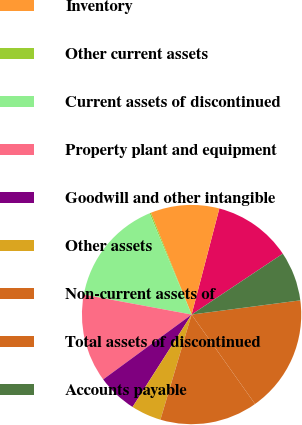<chart> <loc_0><loc_0><loc_500><loc_500><pie_chart><fcel>Accounts receivable<fcel>Inventory<fcel>Other current assets<fcel>Current assets of discontinued<fcel>Property plant and equipment<fcel>Goodwill and other intangible<fcel>Other assets<fcel>Non-current assets of<fcel>Total assets of discontinued<fcel>Accounts payable<nl><fcel>11.56%<fcel>10.14%<fcel>0.19%<fcel>15.83%<fcel>12.99%<fcel>5.88%<fcel>4.46%<fcel>14.41%<fcel>17.25%<fcel>7.3%<nl></chart> 